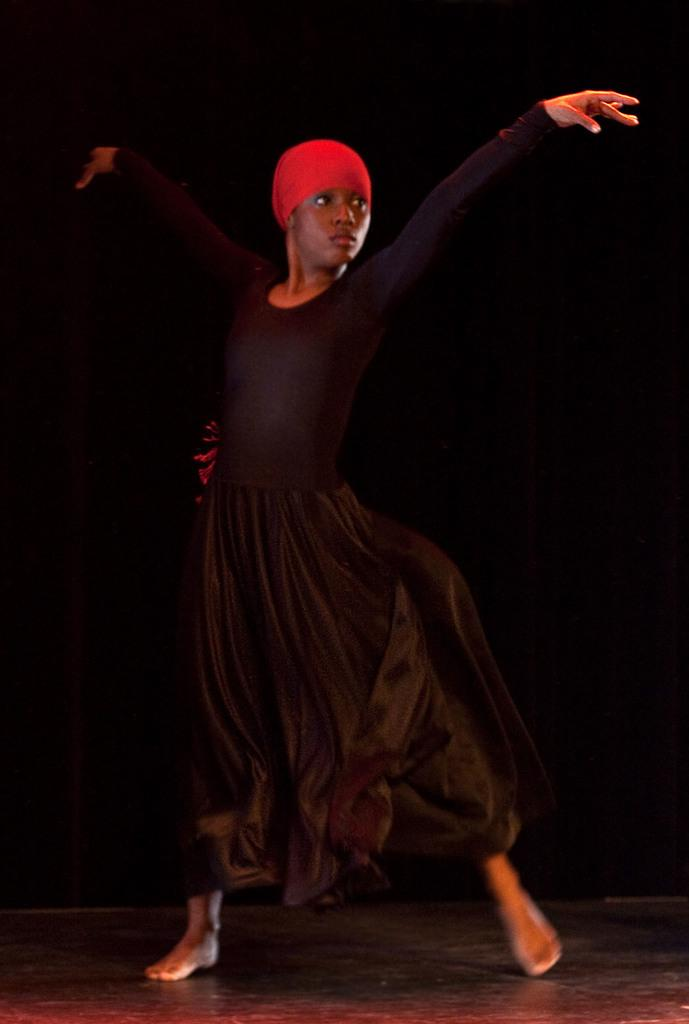Who is the main subject in the image? There is a girl in the image. What is the girl doing in the image? The girl is dancing. What is the girl wearing in the image? The girl is wearing a black dress. What can be seen in the background of the image? The background of the image is dark. What type of celery is being used as a prop in the girl's dance routine? There is no celery present in the image, and therefore no such prop is being used in the girl's dance routine. 